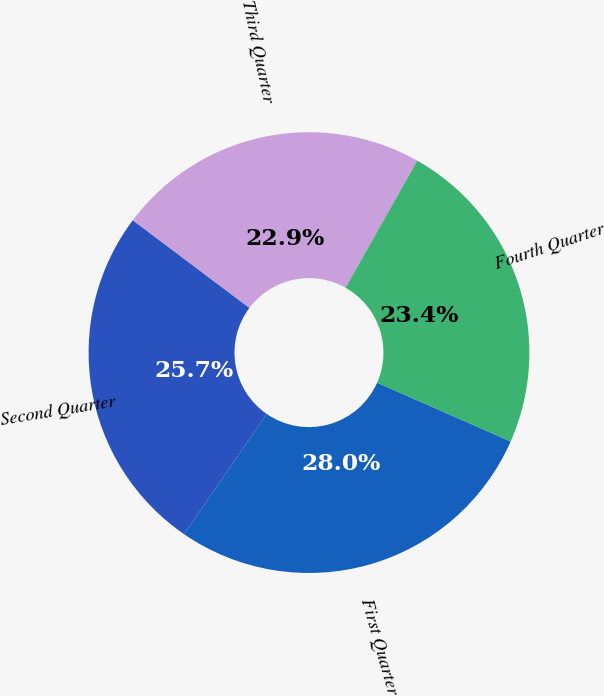Convert chart to OTSL. <chart><loc_0><loc_0><loc_500><loc_500><pie_chart><fcel>First Quarter<fcel>Second Quarter<fcel>Third Quarter<fcel>Fourth Quarter<nl><fcel>27.99%<fcel>25.66%<fcel>22.92%<fcel>23.43%<nl></chart> 